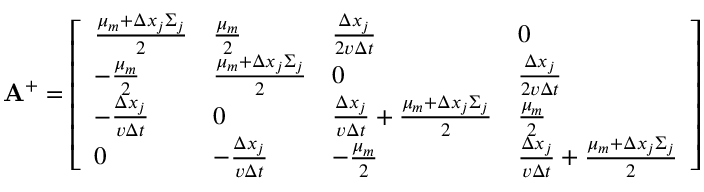<formula> <loc_0><loc_0><loc_500><loc_500>A ^ { + } = \left [ \begin{array} { l l l l } { \frac { \mu _ { m } + \Delta x _ { j } \Sigma _ { j } } { 2 } } & { \frac { \mu _ { m } } { 2 } } & { \frac { \Delta x _ { j } } { 2 v \Delta t } } & { 0 } \\ { - \frac { \mu _ { m } } { 2 } } & { \frac { \mu _ { m } + \Delta x _ { j } \Sigma _ { j } } { 2 } } & { 0 } & { \frac { \Delta x _ { j } } { 2 v \Delta t } } \\ { - \frac { \Delta x _ { j } } { v \Delta t } } & { 0 } & { \frac { \Delta x _ { j } } { v \Delta t } + \frac { \mu _ { m } + \Delta x _ { j } \Sigma _ { j } } { 2 } } & { \frac { \mu _ { m } } { 2 } } \\ { 0 } & { - \frac { \Delta x _ { j } } { v \Delta t } } & { - \frac { \mu _ { m } } { 2 } } & { \frac { \Delta x _ { j } } { v \Delta t } + \frac { \mu _ { m } + \Delta x _ { j } \Sigma _ { j } } { 2 } } \end{array} \right ]</formula> 